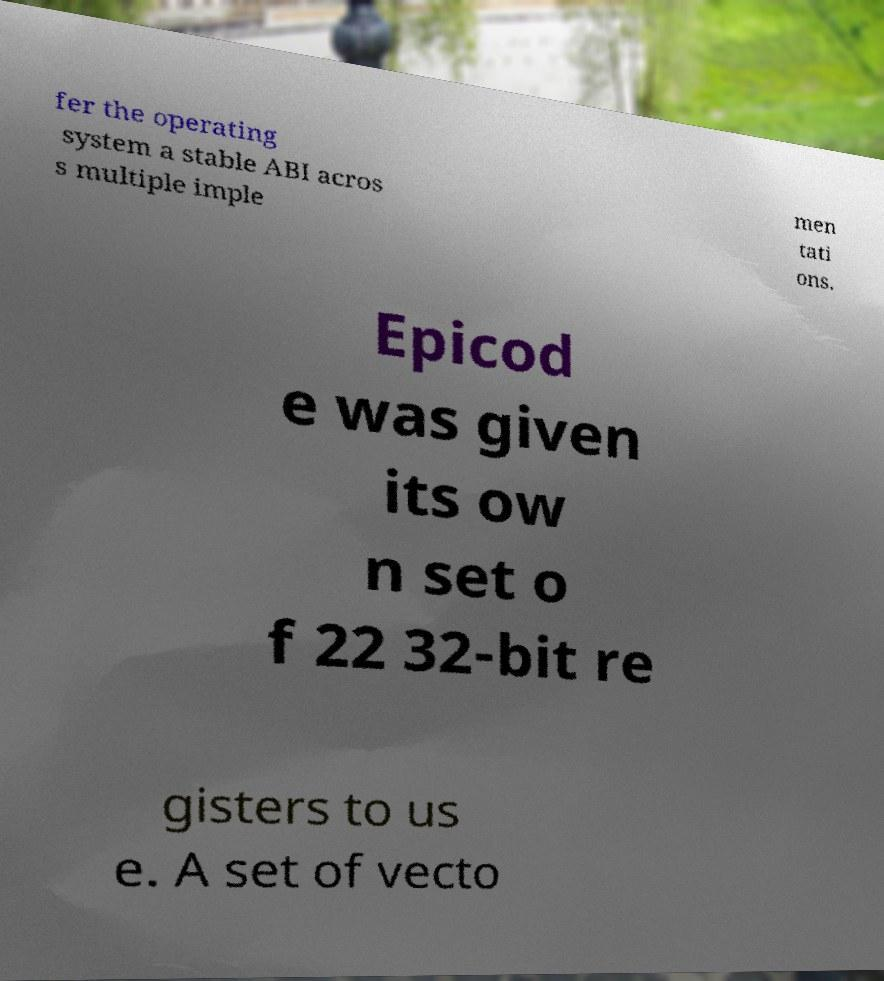Please identify and transcribe the text found in this image. fer the operating system a stable ABI acros s multiple imple men tati ons. Epicod e was given its ow n set o f 22 32-bit re gisters to us e. A set of vecto 